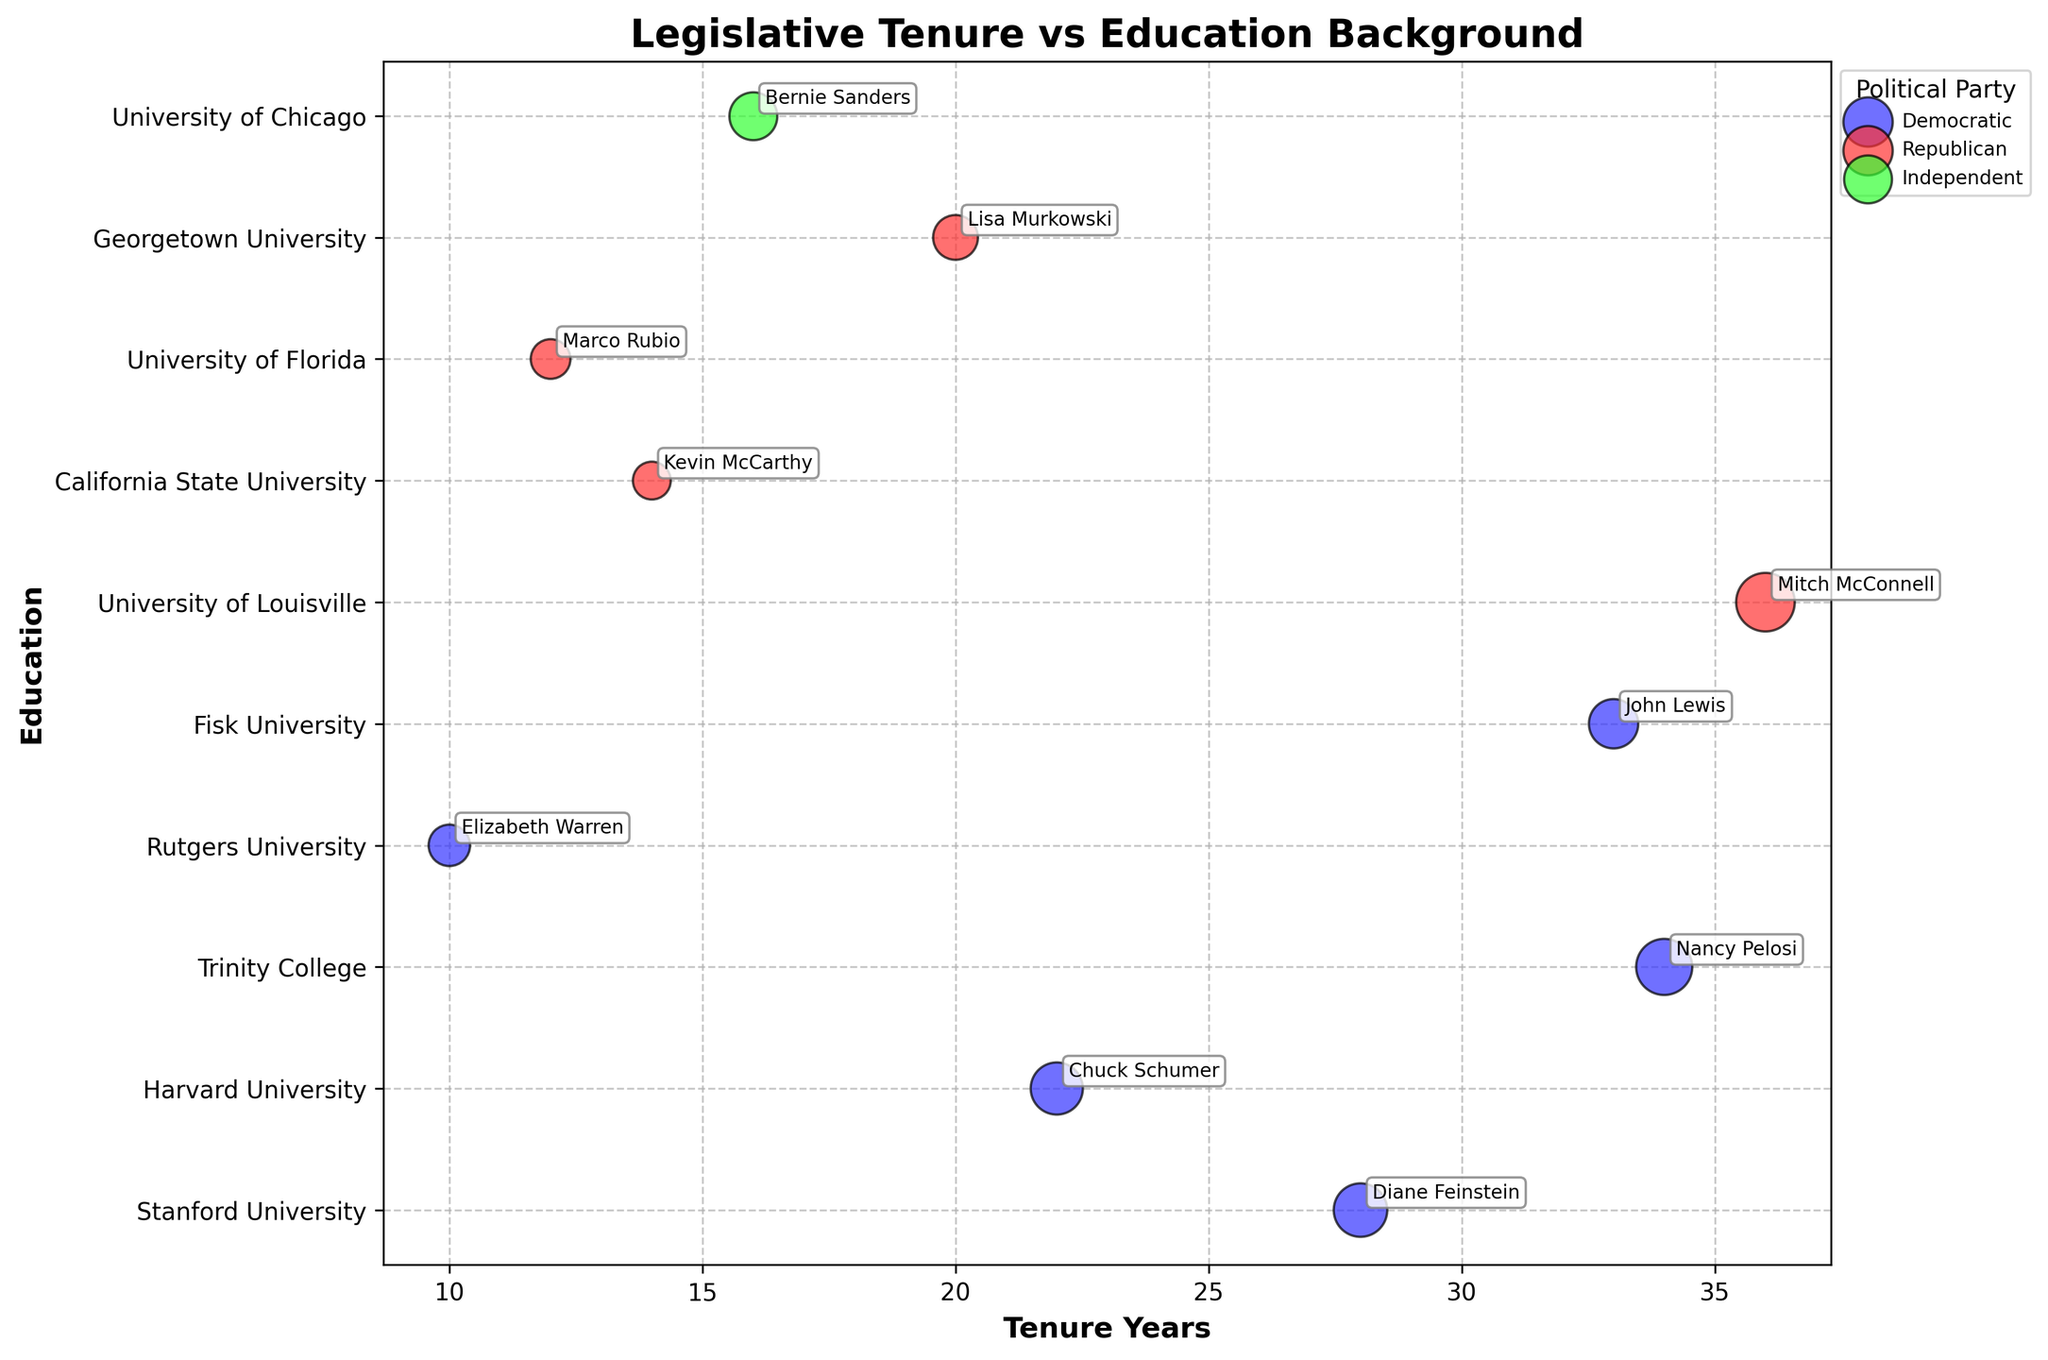Who has the longest tenure among the senators and representatives? By examining the tenure years (x-axis), Mitch McConnell, with 36 years of service, has the longest tenure.
Answer: Mitch McConnell What is the party affiliation of the senator with the shortest tenure? By referring to the size of the bubbles and the x-axis, Kevin McCarthy, with the smallest size bubble at 14 years, belongs to the Republican Party.
Answer: Republican Which senator or representative has a Harvard University background, and how many years have they served? By checking annotations near the "Harvard University" on the education axis, Chuck Schumer is identified, and he has 22 years of service.
Answer: Chuck Schumer, 22 years Who has the second-longest tenure among the Democratic Party members? To find the Democratic members and compare their tenures, Nancy Pelosi has 34 years, and John Lewis follows with 33 years. Thus, John Lewis is second-longest.
Answer: John Lewis Compare the tenures of Mitch McConnell and Bernie Sanders. Who has served longer, and by how many years? Mitch McConnell and Bernie Sanders have tenures of 36 years and 16 years, respectively. The difference is calculated as 36 - 16 = 20 years.
Answer: Mitch McConnell, by 20 years What is the most frequent educational background among the senators and representatives? By assessing the educational background annotations, "University" appears frequently, with multiple individuals attending different universities (e.g., University of Louisville, Stanford University).
Answer: University-related backgrounds Which names represent individuals in the Independent Party? Looking for the color code associated with the Independent Party (#33FF33), we observe that Bernie Sanders, with a green bubble, belongs to the Independent Party.
Answer: Bernie Sanders How does the size of Nancy Pelosi's bubble compare to Elizabeth Warren's? Nancy Pelosi has a bubble size of 110, whereas Elizabeth Warren's bubble size is 60. Therefore, Nancy Pelosi's bubble is larger.
Answer: Nancy Pelosi's bubble is larger Identify any clusters or patterns of senators and representatives by their tenure lengths. Observations reveal that Democratic Party members span tenures between 10 to 34 years primarily, whereas Republicans are widely spread, with a notable cluster at higher tenures like 36 years for Mitch McConnell.
Answer: Democratic members cluster between 10-34 years; Republicans spread widely What is the range of tenures among the senators and representatives in the graph? The shortest tenure is Kevin McCarthy's 14 years, and the longest is Mitch McConnell's 36 years. The tenure range is 36 - 14 = 22 years.
Answer: 22 years 